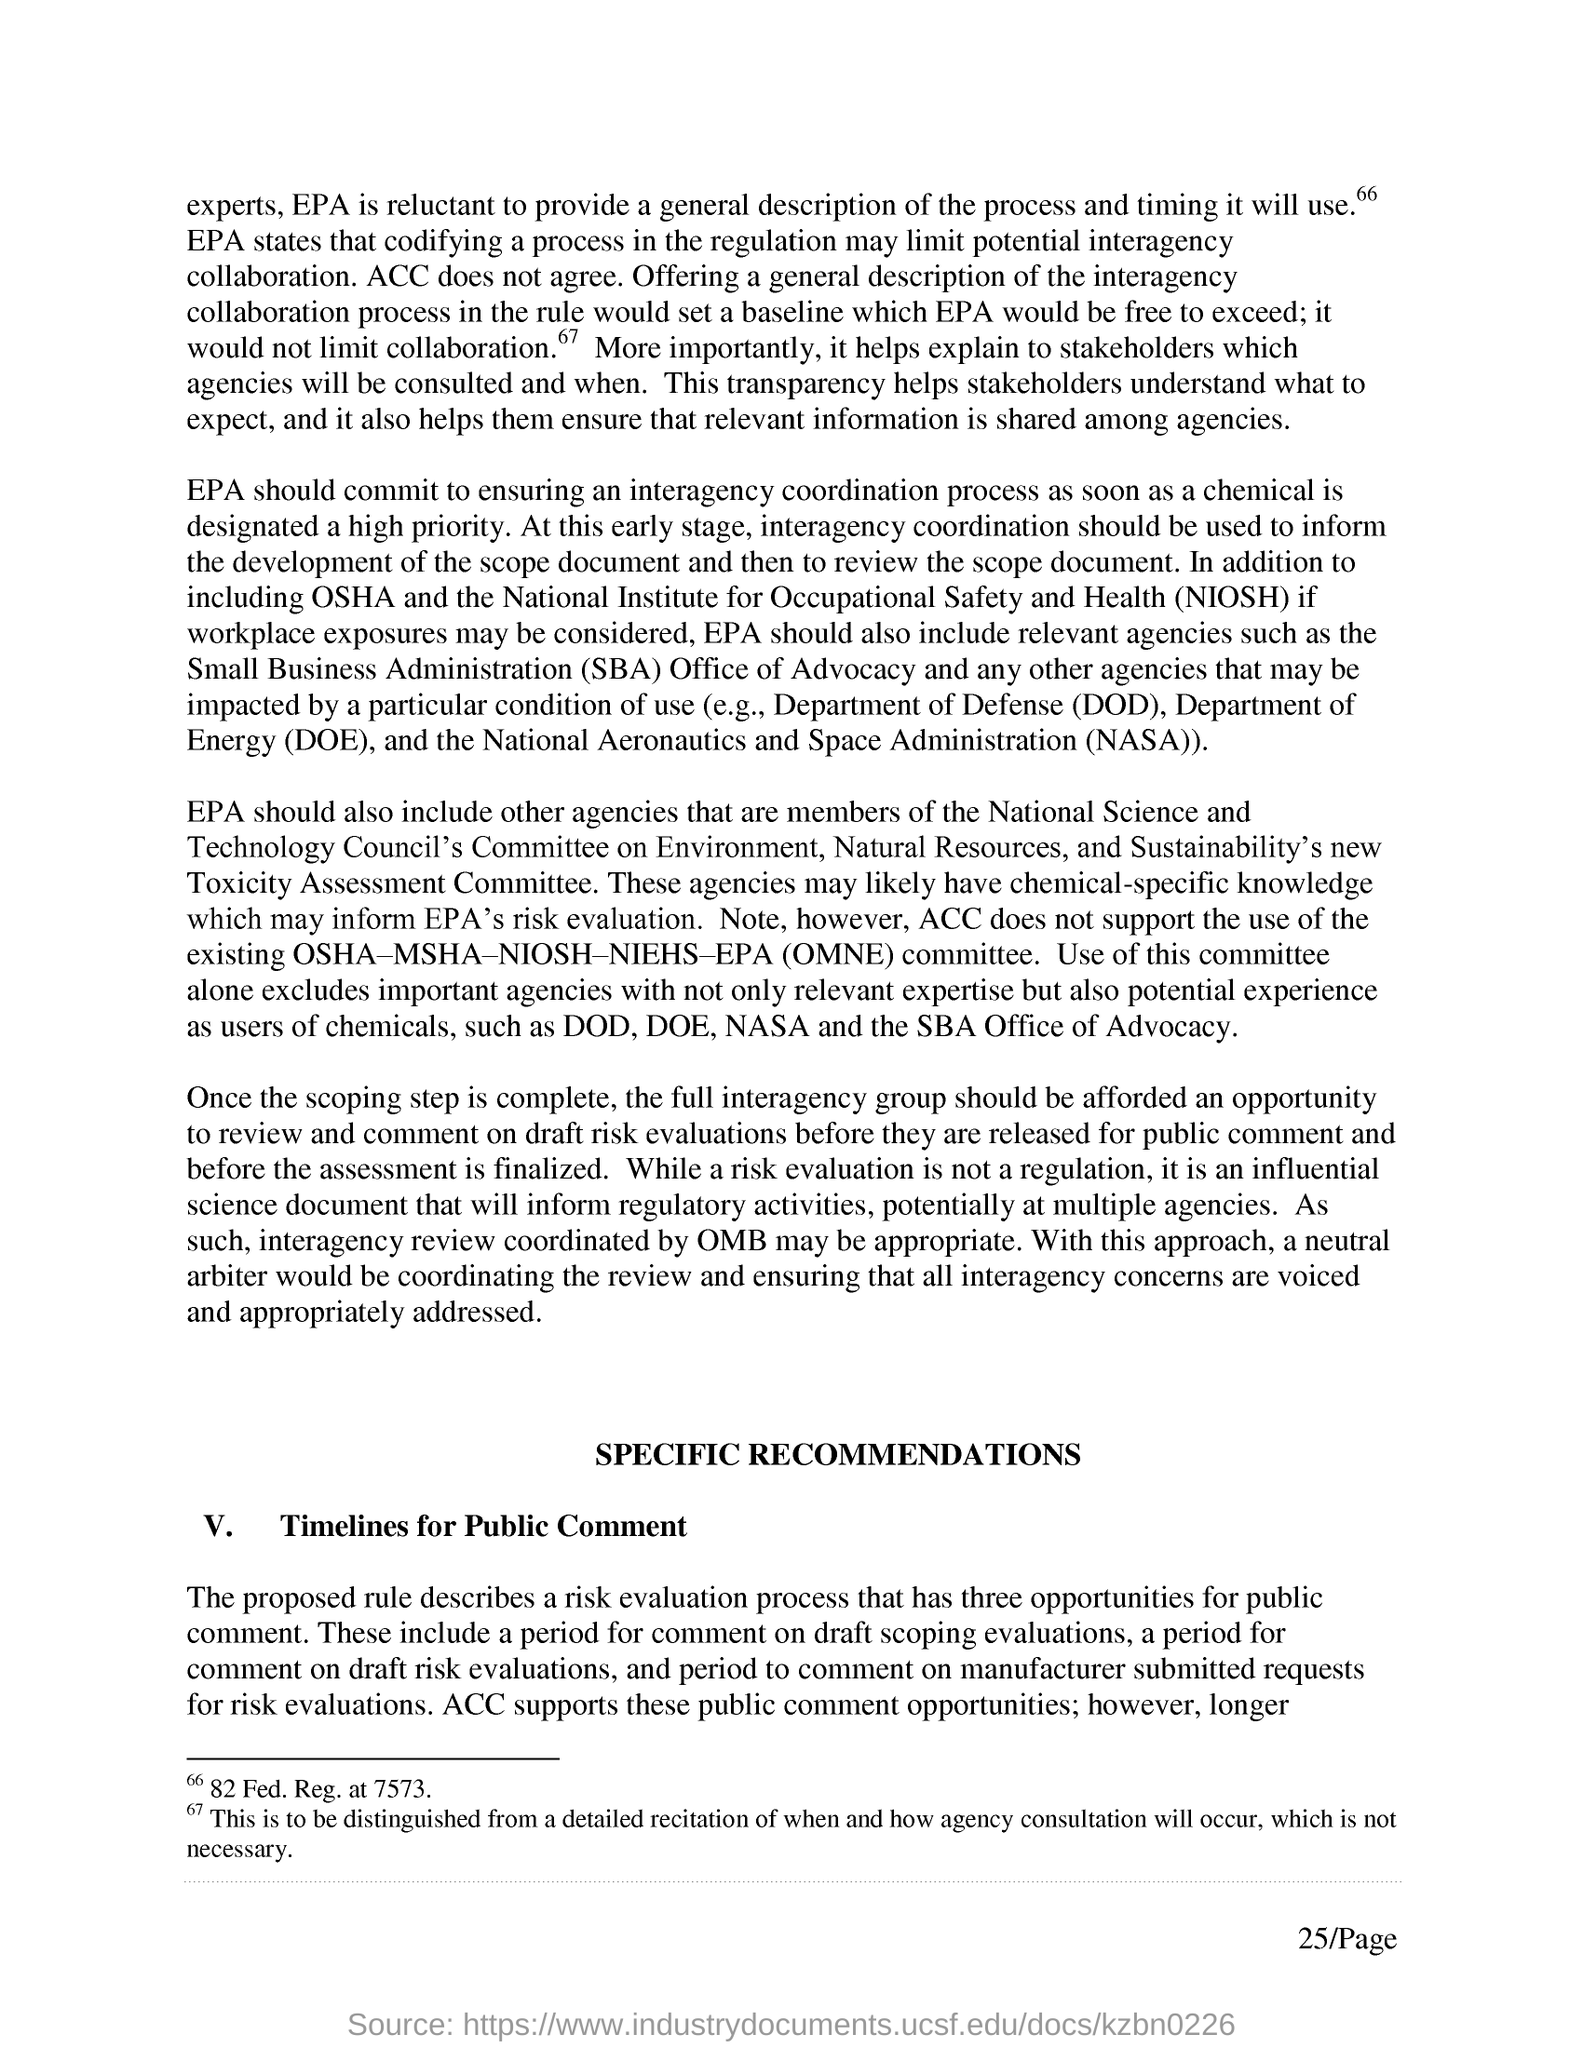What is the full form of SBA?
Give a very brief answer. Small Business Administration. What is the full form of DOD?
Offer a very short reply. Department of Defense. 